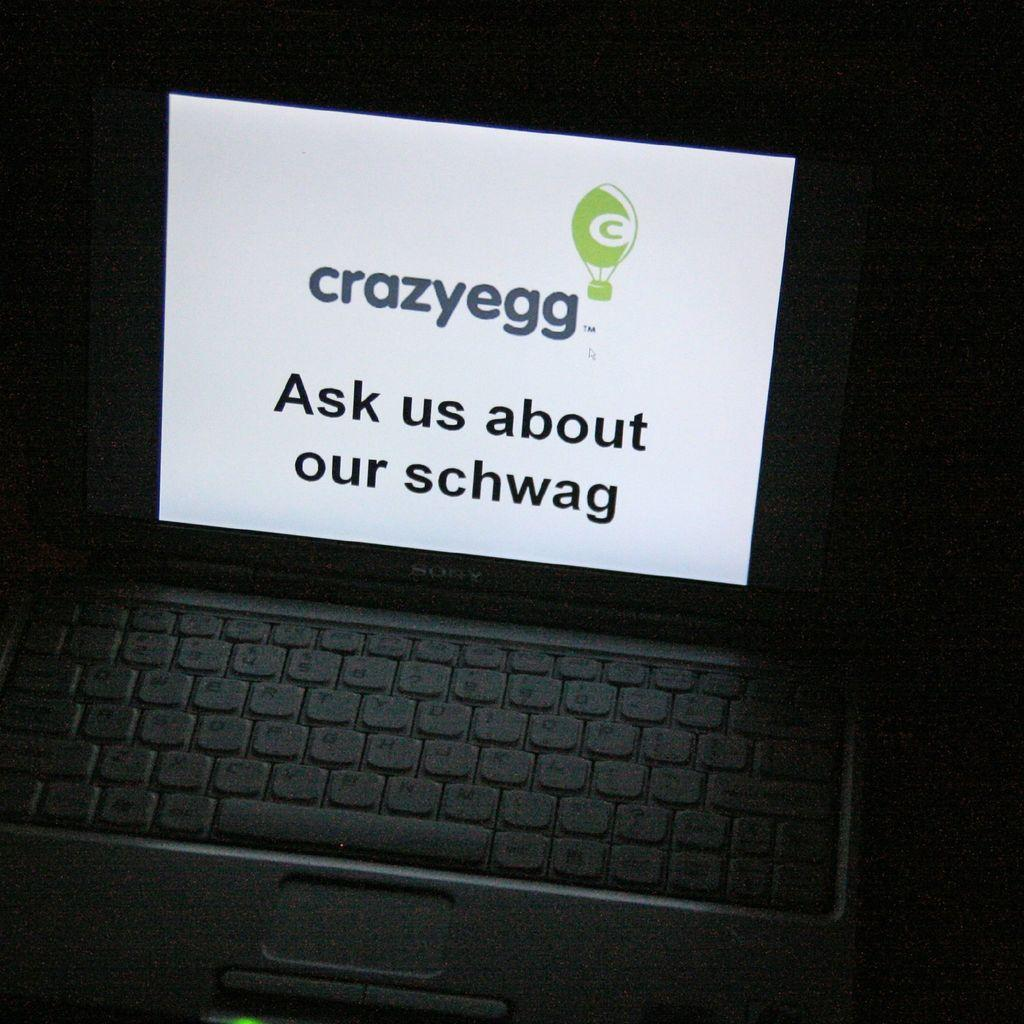<image>
Describe the image concisely. the word schwag is on the screen on the laptop 